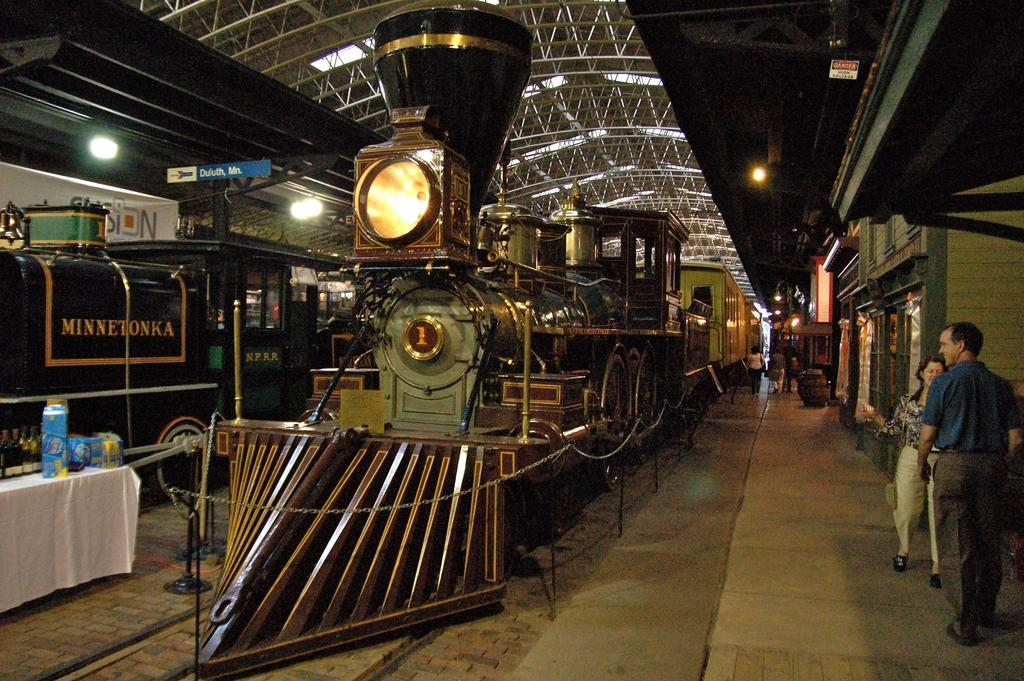What is the main subject of the image? There is a train in the image. Can you describe any additional features near the train? There is a light near the train. Are there any people visible in the image? Yes, there are people visible in the image. What else can be seen on the train or in the surrounding area? There are lights on the roof in the image. What type of ground can be seen beneath the train in the image? There is no ground visible beneath the train in the image; it appears to be elevated or on a platform. Is there any blood visible on the train or on the people in the image? No, there is no blood visible in the image. 